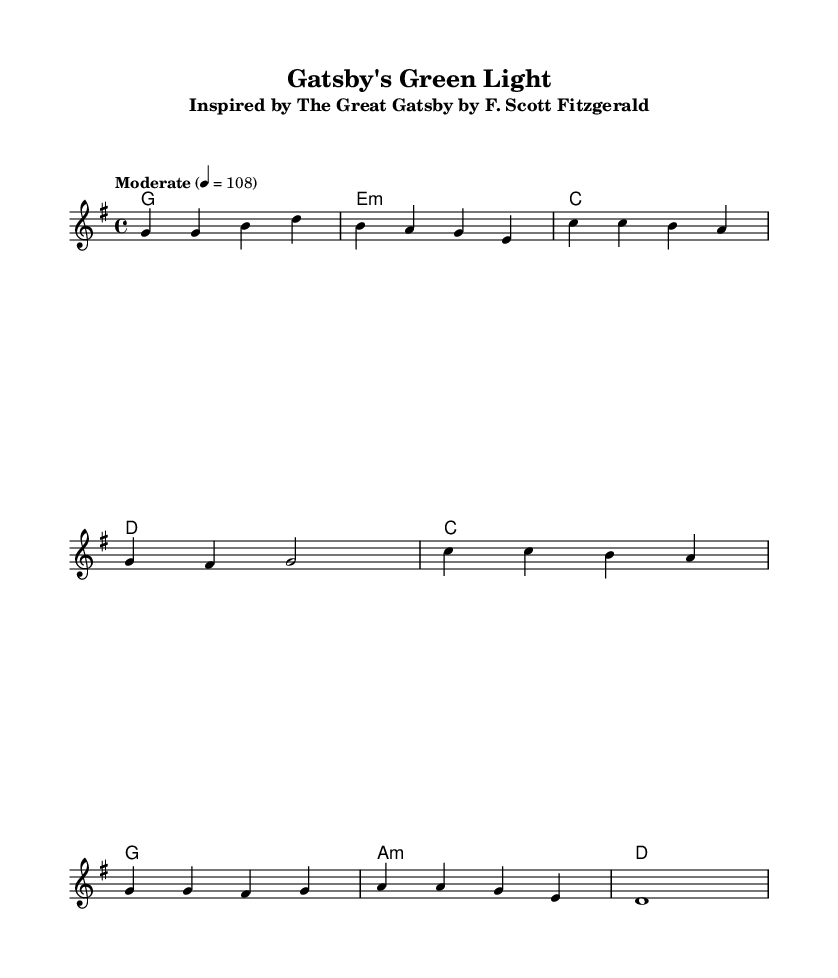What is the key signature of this music? The key signature is G major, which has one sharp (F#). This can be identified from the key signature marking at the beginning of the staff, indicating that the music is to be played in G major.
Answer: G major What is the time signature of this music? The time signature is 4/4, which indicates four beats per measure. This is visible in the time signature marking at the beginning of the sheet music that shows a "4" over another "4".
Answer: 4/4 What is the tempo marking for this piece? The tempo marking is "Moderate" with a speed indication of 4 = 108. This tempo is shown just after the global settings, indicating the desired pace at which the piece should be played.
Answer: Moderate How many measures are in the verse? There are four measures in the verse, as shown by the line breaks and the counts of notes within the verse section of the sheet music. Each line consists of one measure, totaling four.
Answer: 4 Which classic American novel inspired this song? This song is inspired by "The Great Gatsby" by F. Scott Fitzgerald, as indicated in the subtitle of the header section of the sheet music. The title "Gatsby's Green Light" also refers to significant themes from the novel.
Answer: The Great Gatsby What is the title of this song? The title of the song is "Gatsby's Green Light," as specified in the header section of the sheet music. This title reflects the central theme and inspiration drawn from the mentioned novel.
Answer: Gatsby's Green Light 